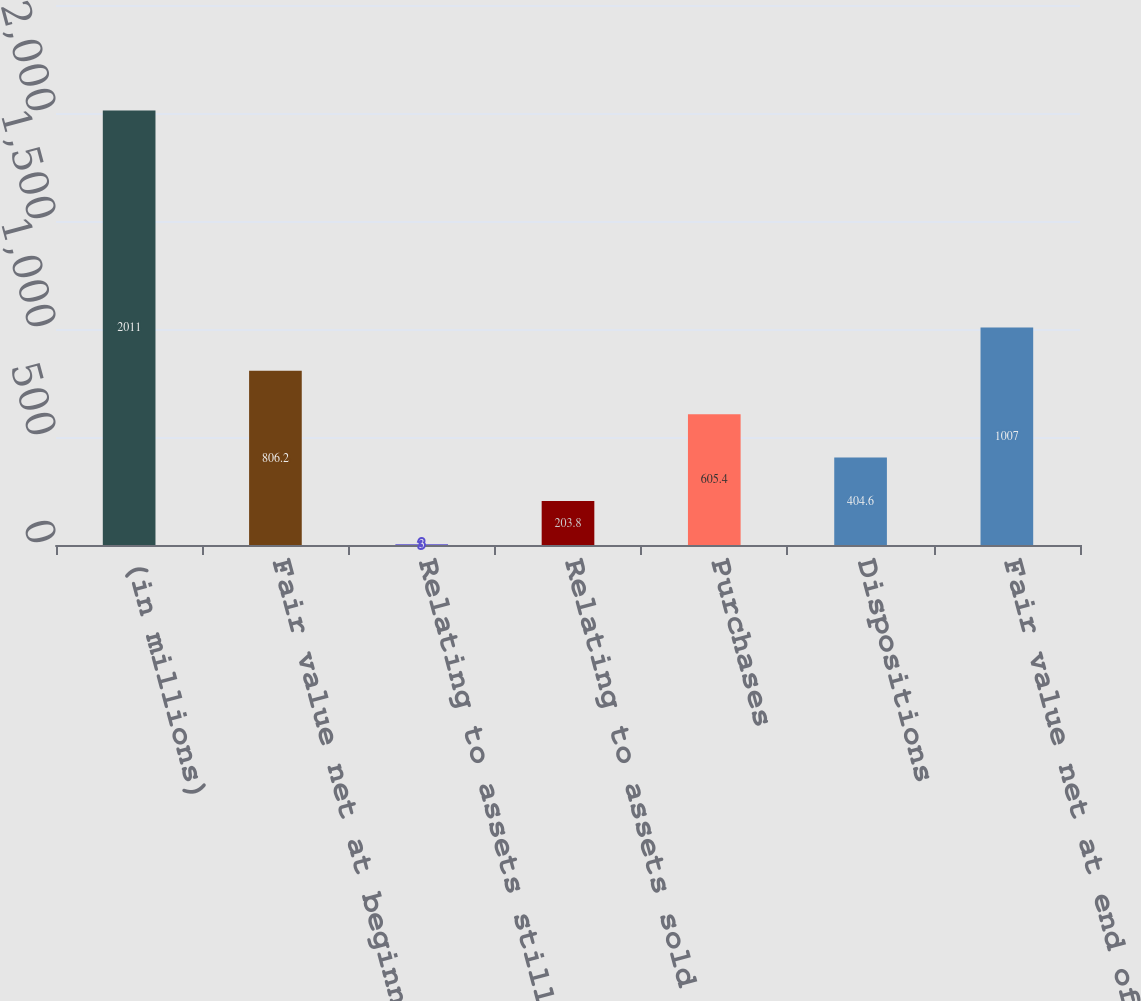<chart> <loc_0><loc_0><loc_500><loc_500><bar_chart><fcel>(in millions)<fcel>Fair value net at beginning of<fcel>Relating to assets still held<fcel>Relating to assets sold during<fcel>Purchases<fcel>Dispositions<fcel>Fair value net at end of<nl><fcel>2011<fcel>806.2<fcel>3<fcel>203.8<fcel>605.4<fcel>404.6<fcel>1007<nl></chart> 